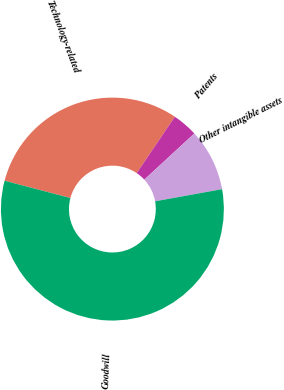Convert chart to OTSL. <chart><loc_0><loc_0><loc_500><loc_500><pie_chart><fcel>Technology-related<fcel>Patents<fcel>Other intangible assets<fcel>Goodwill<nl><fcel>30.37%<fcel>3.68%<fcel>9.0%<fcel>56.95%<nl></chart> 